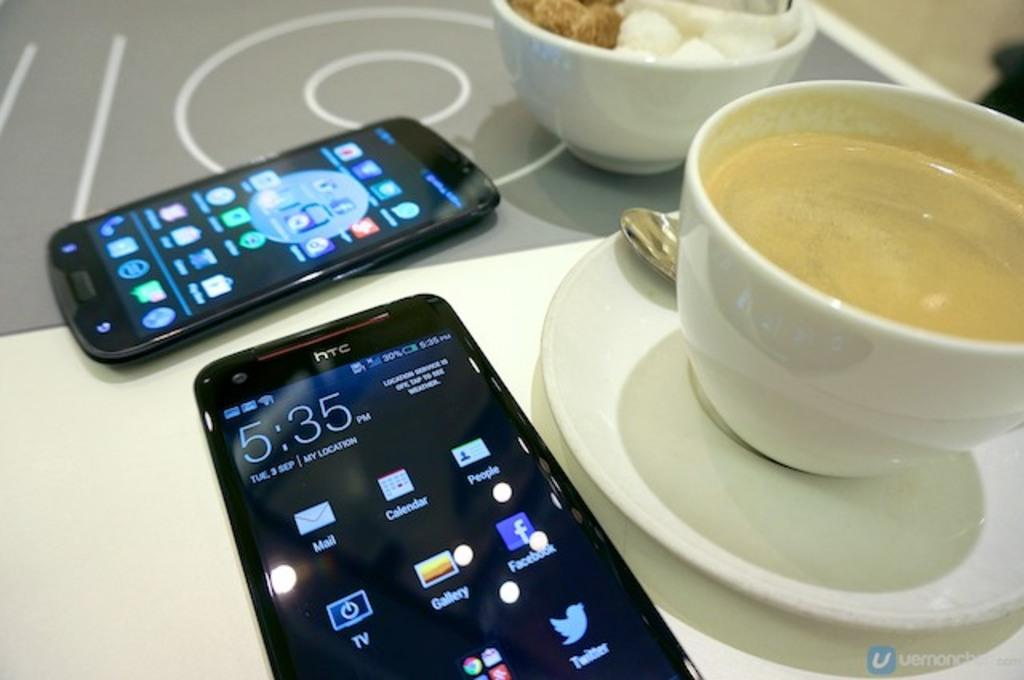<image>
Create a compact narrative representing the image presented. Two smartphones, one an HTC that displays the time as 5:35 pm, sit on a table. 